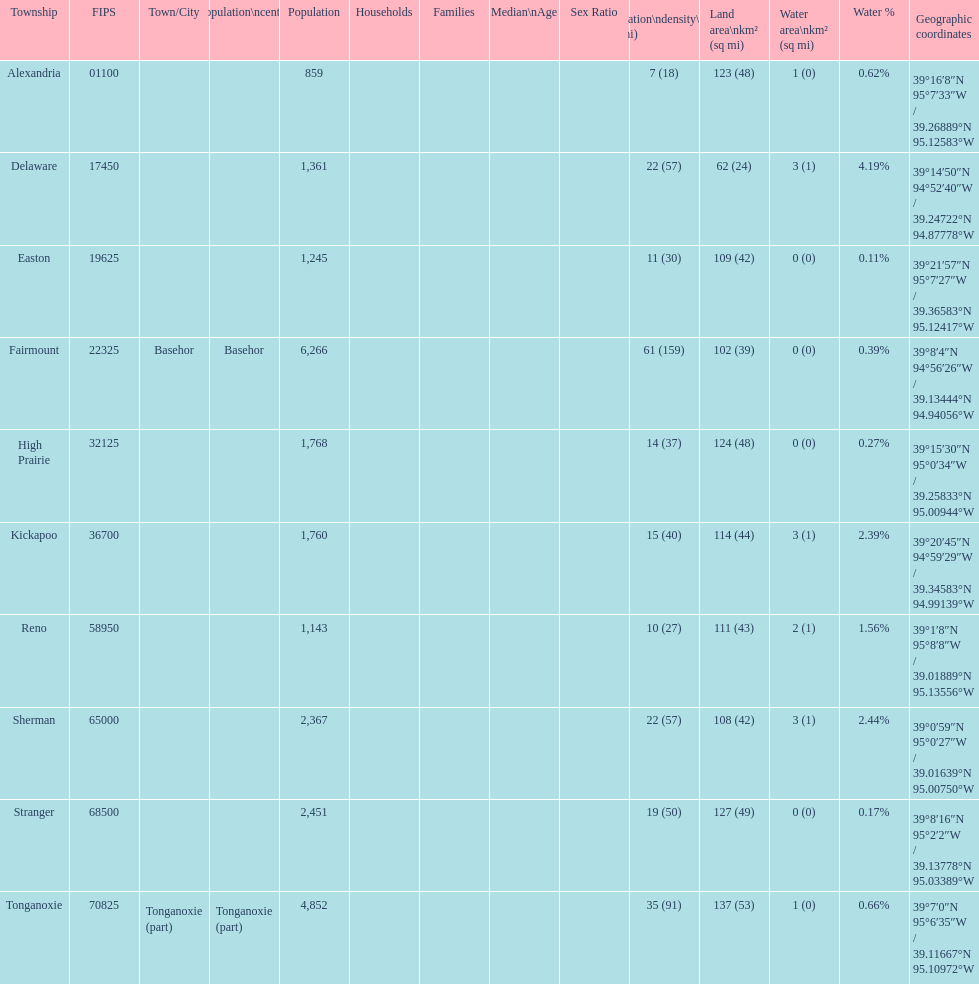What township has the largest population? Fairmount. 